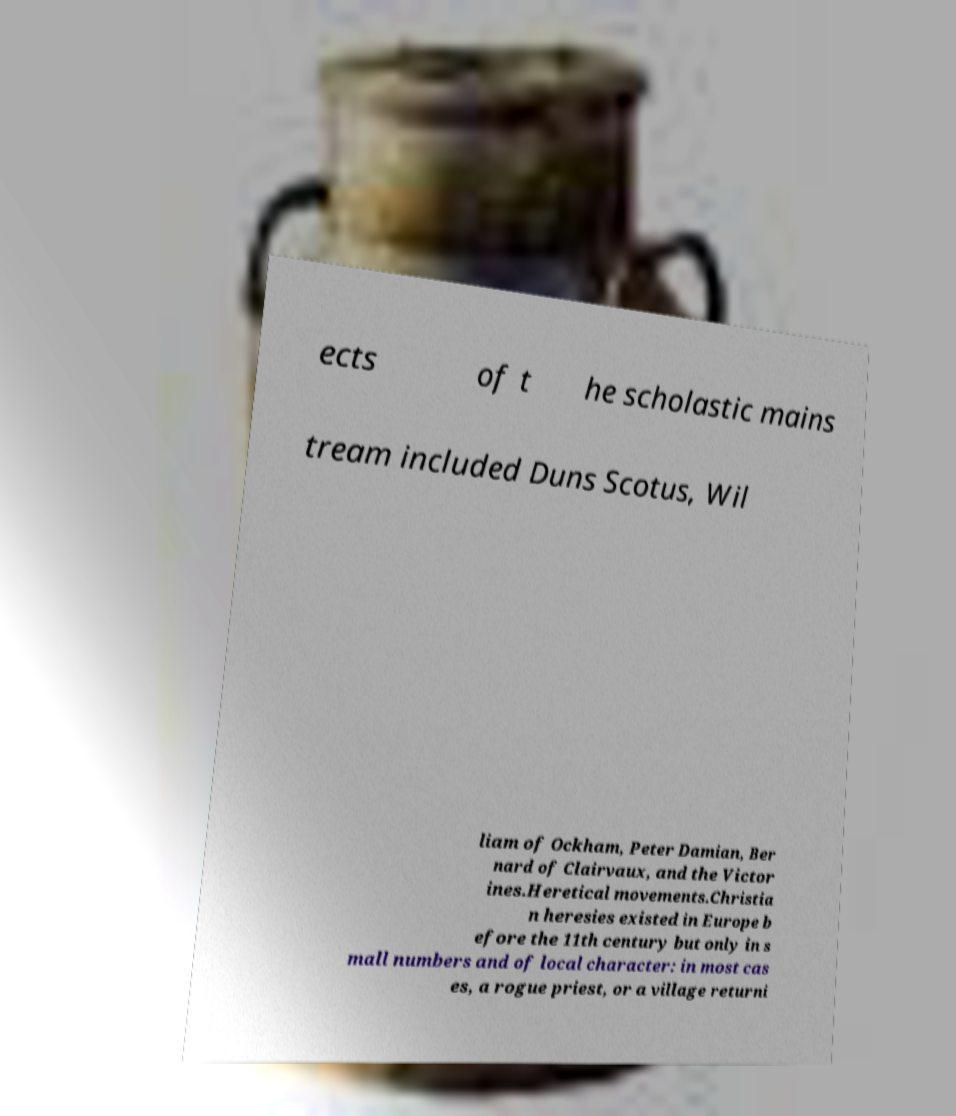There's text embedded in this image that I need extracted. Can you transcribe it verbatim? ects of t he scholastic mains tream included Duns Scotus, Wil liam of Ockham, Peter Damian, Ber nard of Clairvaux, and the Victor ines.Heretical movements.Christia n heresies existed in Europe b efore the 11th century but only in s mall numbers and of local character: in most cas es, a rogue priest, or a village returni 